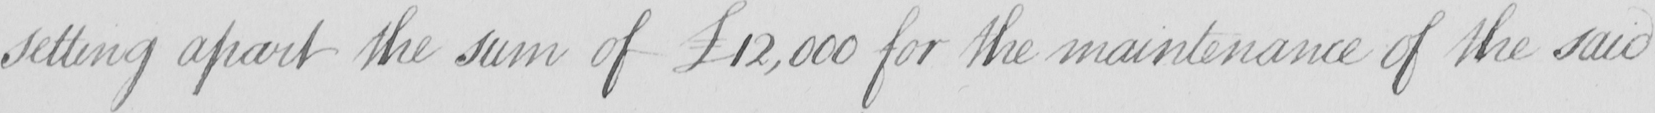What is written in this line of handwriting? setting apart the sum of £12,000 for the maintenance of the said 